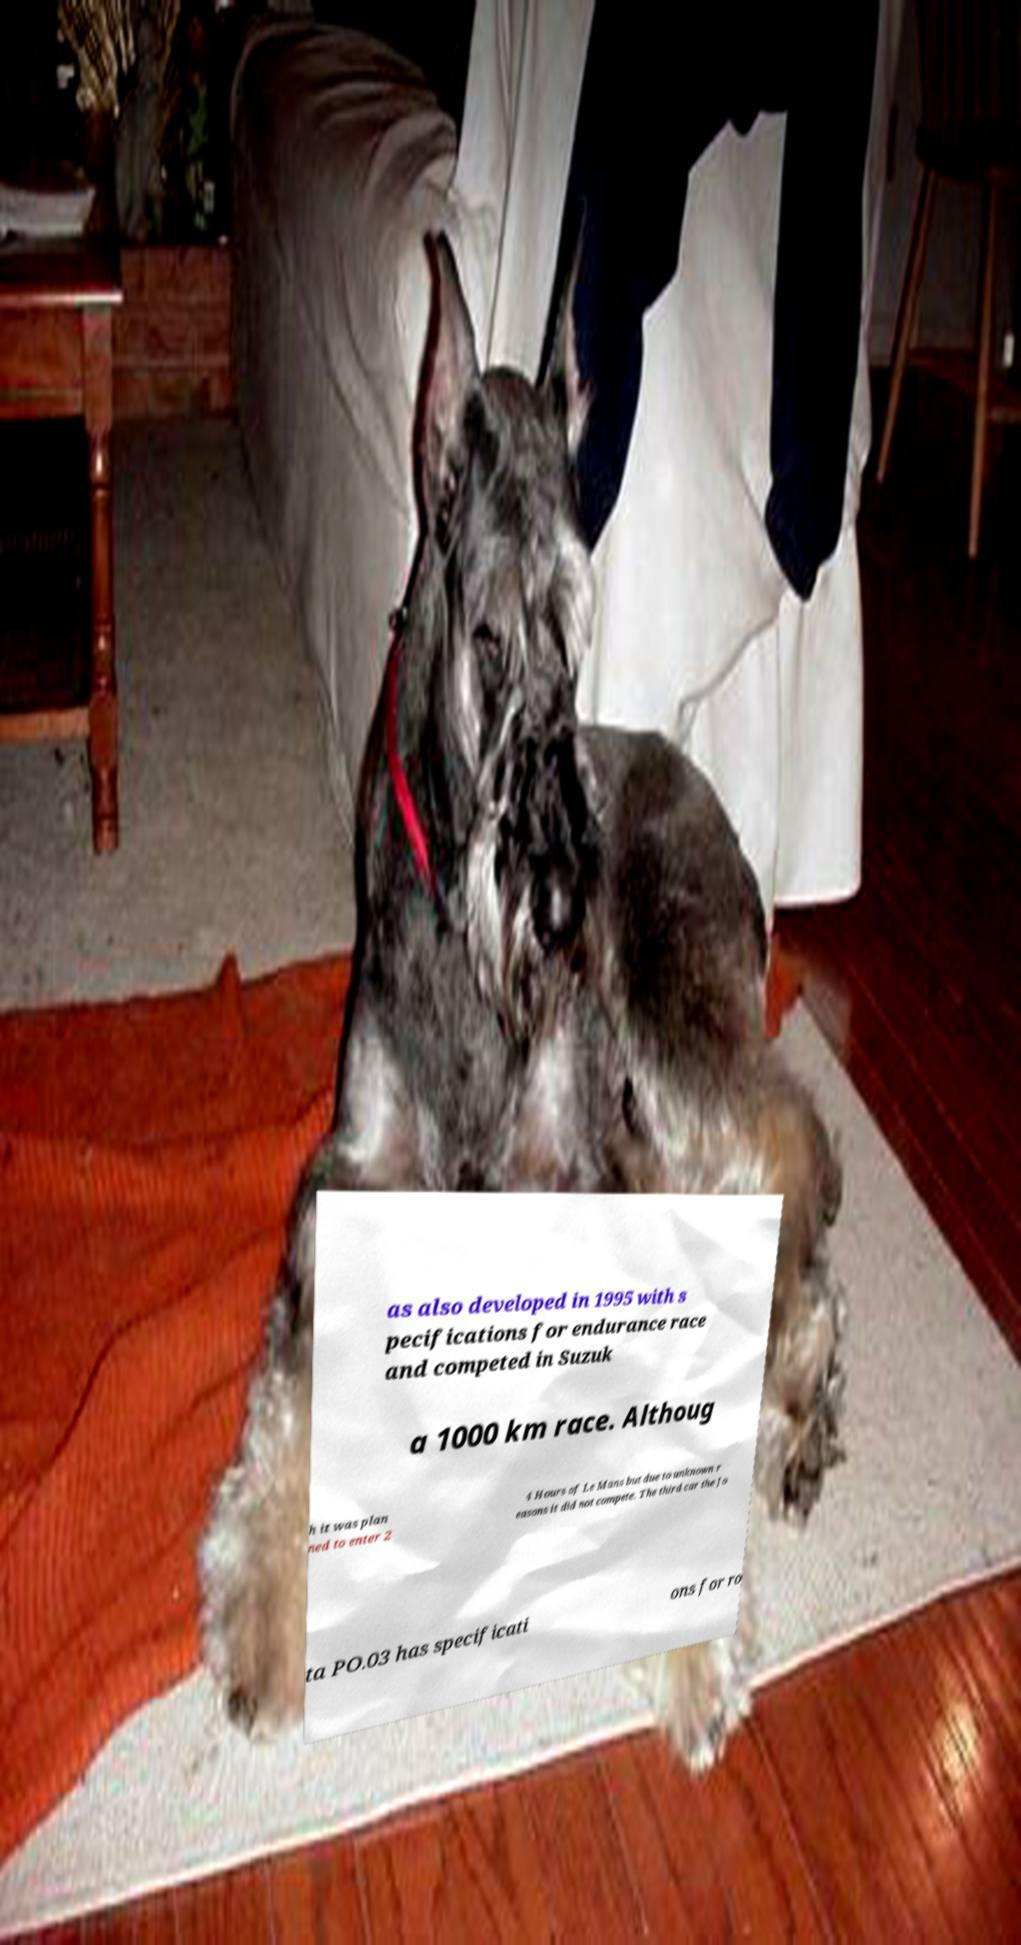Could you assist in decoding the text presented in this image and type it out clearly? as also developed in 1995 with s pecifications for endurance race and competed in Suzuk a 1000 km race. Althoug h it was plan ned to enter 2 4 Hours of Le Mans but due to unknown r easons it did not compete. The third car the Jo ta PO.03 has specificati ons for ro 